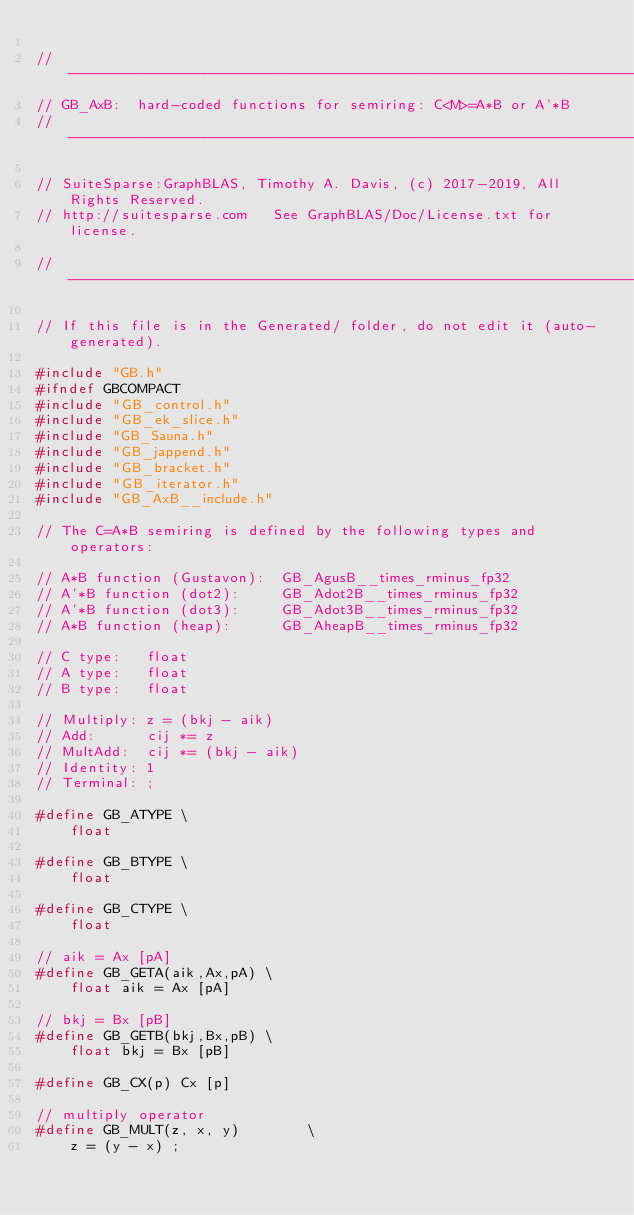Convert code to text. <code><loc_0><loc_0><loc_500><loc_500><_C_>
//------------------------------------------------------------------------------
// GB_AxB:  hard-coded functions for semiring: C<M>=A*B or A'*B
//------------------------------------------------------------------------------

// SuiteSparse:GraphBLAS, Timothy A. Davis, (c) 2017-2019, All Rights Reserved.
// http://suitesparse.com   See GraphBLAS/Doc/License.txt for license.

//------------------------------------------------------------------------------

// If this file is in the Generated/ folder, do not edit it (auto-generated).

#include "GB.h"
#ifndef GBCOMPACT
#include "GB_control.h"
#include "GB_ek_slice.h"
#include "GB_Sauna.h"
#include "GB_jappend.h"
#include "GB_bracket.h"
#include "GB_iterator.h"
#include "GB_AxB__include.h"

// The C=A*B semiring is defined by the following types and operators:

// A*B function (Gustavon):  GB_AgusB__times_rminus_fp32
// A'*B function (dot2):     GB_Adot2B__times_rminus_fp32
// A'*B function (dot3):     GB_Adot3B__times_rminus_fp32
// A*B function (heap):      GB_AheapB__times_rminus_fp32

// C type:   float
// A type:   float
// B type:   float

// Multiply: z = (bkj - aik)
// Add:      cij *= z
// MultAdd:  cij *= (bkj - aik)
// Identity: 1
// Terminal: ;

#define GB_ATYPE \
    float

#define GB_BTYPE \
    float

#define GB_CTYPE \
    float

// aik = Ax [pA]
#define GB_GETA(aik,Ax,pA) \
    float aik = Ax [pA]

// bkj = Bx [pB]
#define GB_GETB(bkj,Bx,pB) \
    float bkj = Bx [pB]

#define GB_CX(p) Cx [p]

// multiply operator
#define GB_MULT(z, x, y)        \
    z = (y - x) ;
</code> 